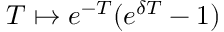<formula> <loc_0><loc_0><loc_500><loc_500>T \mapsto e ^ { - T } ( e ^ { \delta T } - 1 )</formula> 